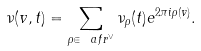<formula> <loc_0><loc_0><loc_500><loc_500>\nu ( v , t ) = \sum _ { \rho \in \ a f r ^ { \lor } } \nu _ { \rho } ( t ) e ^ { 2 \pi i \rho ( v ) } .</formula> 